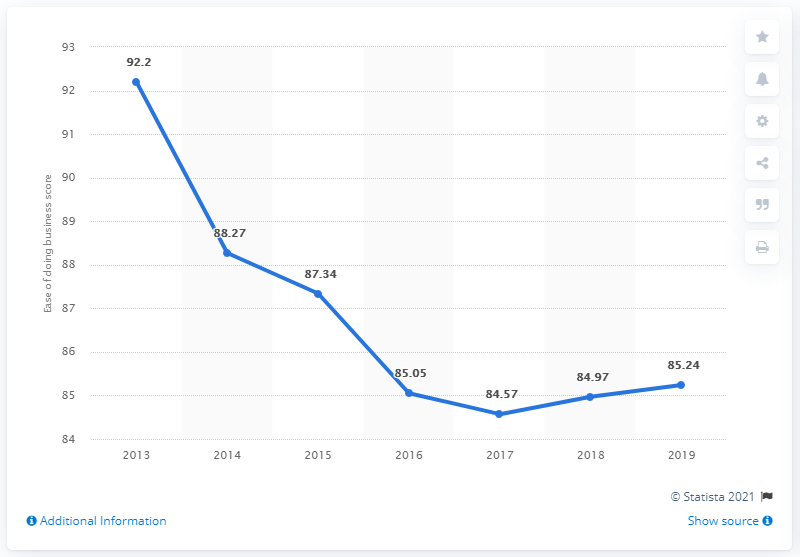Indicate a few pertinent items in this graphic. In 2019, Singapore's ease of doing business score was 85.24, which indicated a high level of business friendliness and competitiveness in the country. 